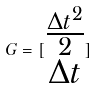Convert formula to latex. <formula><loc_0><loc_0><loc_500><loc_500>G = [ \begin{matrix} \frac { \Delta t ^ { 2 } } { 2 } \\ \Delta t \end{matrix} ]</formula> 